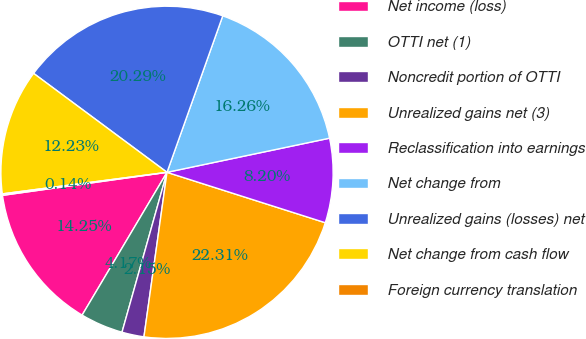<chart> <loc_0><loc_0><loc_500><loc_500><pie_chart><fcel>Net income (loss)<fcel>OTTI net (1)<fcel>Noncredit portion of OTTI<fcel>Unrealized gains net (3)<fcel>Reclassification into earnings<fcel>Net change from<fcel>Unrealized gains (losses) net<fcel>Net change from cash flow<fcel>Foreign currency translation<nl><fcel>14.25%<fcel>4.17%<fcel>2.15%<fcel>22.31%<fcel>8.2%<fcel>16.26%<fcel>20.29%<fcel>12.23%<fcel>0.14%<nl></chart> 